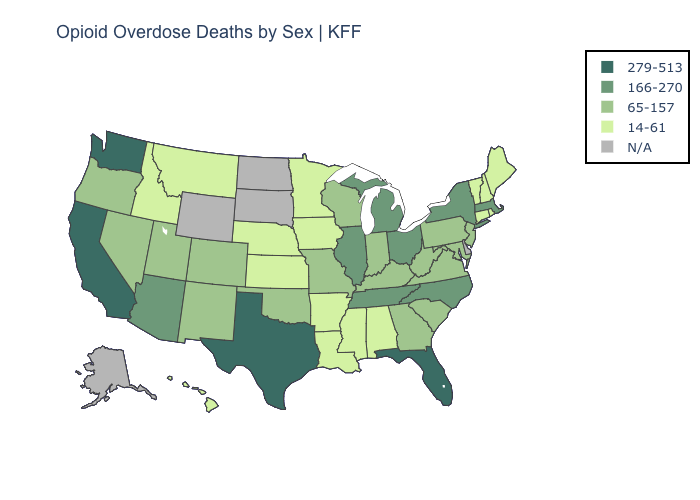Does Connecticut have the lowest value in the Northeast?
Be succinct. Yes. Name the states that have a value in the range 279-513?
Keep it brief. California, Florida, Texas, Washington. Name the states that have a value in the range N/A?
Give a very brief answer. Alaska, Delaware, North Dakota, South Dakota, Wyoming. Name the states that have a value in the range N/A?
Short answer required. Alaska, Delaware, North Dakota, South Dakota, Wyoming. How many symbols are there in the legend?
Give a very brief answer. 5. What is the value of Iowa?
Quick response, please. 14-61. Among the states that border Nebraska , does Iowa have the highest value?
Give a very brief answer. No. Name the states that have a value in the range 279-513?
Quick response, please. California, Florida, Texas, Washington. What is the highest value in states that border Pennsylvania?
Short answer required. 166-270. Name the states that have a value in the range N/A?
Concise answer only. Alaska, Delaware, North Dakota, South Dakota, Wyoming. Does Idaho have the lowest value in the West?
Give a very brief answer. Yes. Which states have the highest value in the USA?
Answer briefly. California, Florida, Texas, Washington. Does Nebraska have the highest value in the MidWest?
Answer briefly. No. 